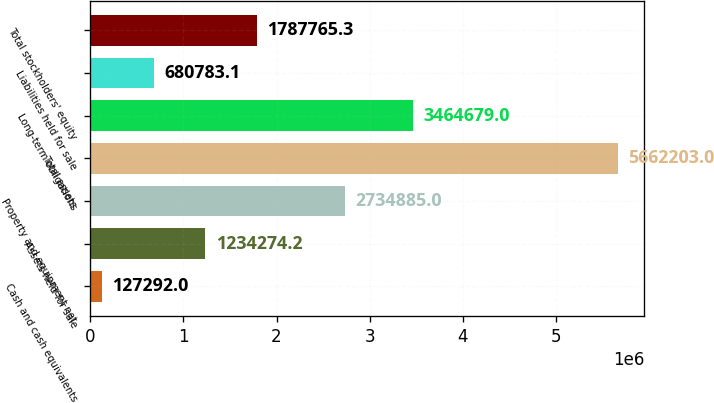<chart> <loc_0><loc_0><loc_500><loc_500><bar_chart><fcel>Cash and cash equivalents<fcel>Assets held for sale<fcel>Property and equipment net<fcel>Total assets<fcel>Long-term obligations<fcel>Liabilities held for sale<fcel>Total stockholders' equity<nl><fcel>127292<fcel>1.23427e+06<fcel>2.73488e+06<fcel>5.6622e+06<fcel>3.46468e+06<fcel>680783<fcel>1.78777e+06<nl></chart> 